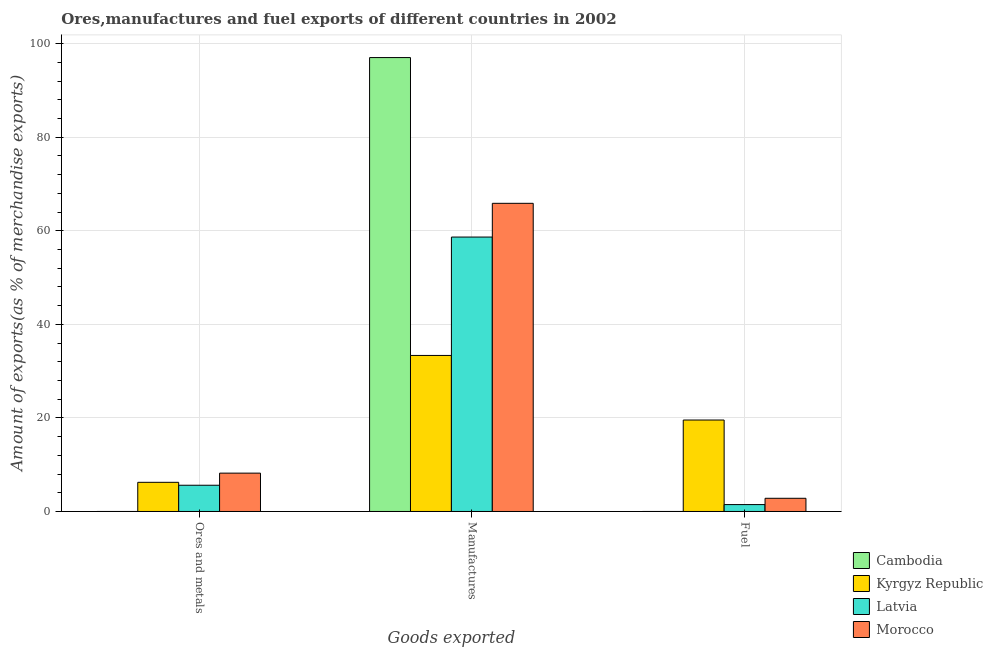How many different coloured bars are there?
Offer a terse response. 4. How many bars are there on the 2nd tick from the left?
Make the answer very short. 4. How many bars are there on the 3rd tick from the right?
Make the answer very short. 4. What is the label of the 3rd group of bars from the left?
Give a very brief answer. Fuel. What is the percentage of manufactures exports in Morocco?
Offer a terse response. 65.86. Across all countries, what is the maximum percentage of manufactures exports?
Your answer should be very brief. 97.02. Across all countries, what is the minimum percentage of manufactures exports?
Provide a short and direct response. 33.35. In which country was the percentage of fuel exports maximum?
Make the answer very short. Kyrgyz Republic. In which country was the percentage of fuel exports minimum?
Your response must be concise. Cambodia. What is the total percentage of manufactures exports in the graph?
Your answer should be compact. 254.89. What is the difference between the percentage of ores and metals exports in Cambodia and that in Morocco?
Your response must be concise. -8.2. What is the difference between the percentage of ores and metals exports in Morocco and the percentage of manufactures exports in Kyrgyz Republic?
Provide a succinct answer. -25.15. What is the average percentage of manufactures exports per country?
Offer a very short reply. 63.72. What is the difference between the percentage of manufactures exports and percentage of fuel exports in Kyrgyz Republic?
Make the answer very short. 13.8. What is the ratio of the percentage of fuel exports in Latvia to that in Cambodia?
Offer a terse response. 2388.65. Is the percentage of fuel exports in Kyrgyz Republic less than that in Latvia?
Make the answer very short. No. Is the difference between the percentage of fuel exports in Cambodia and Kyrgyz Republic greater than the difference between the percentage of manufactures exports in Cambodia and Kyrgyz Republic?
Provide a succinct answer. No. What is the difference between the highest and the second highest percentage of manufactures exports?
Ensure brevity in your answer.  31.15. What is the difference between the highest and the lowest percentage of fuel exports?
Offer a very short reply. 19.55. In how many countries, is the percentage of ores and metals exports greater than the average percentage of ores and metals exports taken over all countries?
Your answer should be compact. 3. Is the sum of the percentage of manufactures exports in Kyrgyz Republic and Cambodia greater than the maximum percentage of fuel exports across all countries?
Keep it short and to the point. Yes. What does the 3rd bar from the left in Ores and metals represents?
Ensure brevity in your answer.  Latvia. What does the 1st bar from the right in Manufactures represents?
Provide a short and direct response. Morocco. What is the difference between two consecutive major ticks on the Y-axis?
Offer a very short reply. 20. Does the graph contain any zero values?
Make the answer very short. No. Where does the legend appear in the graph?
Offer a very short reply. Bottom right. How are the legend labels stacked?
Provide a succinct answer. Vertical. What is the title of the graph?
Your response must be concise. Ores,manufactures and fuel exports of different countries in 2002. Does "Cayman Islands" appear as one of the legend labels in the graph?
Ensure brevity in your answer.  No. What is the label or title of the X-axis?
Ensure brevity in your answer.  Goods exported. What is the label or title of the Y-axis?
Ensure brevity in your answer.  Amount of exports(as % of merchandise exports). What is the Amount of exports(as % of merchandise exports) of Cambodia in Ores and metals?
Make the answer very short. 0. What is the Amount of exports(as % of merchandise exports) of Kyrgyz Republic in Ores and metals?
Offer a very short reply. 6.23. What is the Amount of exports(as % of merchandise exports) of Latvia in Ores and metals?
Your answer should be compact. 5.61. What is the Amount of exports(as % of merchandise exports) in Morocco in Ores and metals?
Give a very brief answer. 8.2. What is the Amount of exports(as % of merchandise exports) in Cambodia in Manufactures?
Provide a short and direct response. 97.02. What is the Amount of exports(as % of merchandise exports) in Kyrgyz Republic in Manufactures?
Your response must be concise. 33.35. What is the Amount of exports(as % of merchandise exports) in Latvia in Manufactures?
Offer a very short reply. 58.66. What is the Amount of exports(as % of merchandise exports) in Morocco in Manufactures?
Your answer should be compact. 65.86. What is the Amount of exports(as % of merchandise exports) of Cambodia in Fuel?
Make the answer very short. 0. What is the Amount of exports(as % of merchandise exports) in Kyrgyz Republic in Fuel?
Offer a very short reply. 19.55. What is the Amount of exports(as % of merchandise exports) in Latvia in Fuel?
Offer a terse response. 1.48. What is the Amount of exports(as % of merchandise exports) of Morocco in Fuel?
Provide a succinct answer. 2.82. Across all Goods exported, what is the maximum Amount of exports(as % of merchandise exports) in Cambodia?
Ensure brevity in your answer.  97.02. Across all Goods exported, what is the maximum Amount of exports(as % of merchandise exports) in Kyrgyz Republic?
Ensure brevity in your answer.  33.35. Across all Goods exported, what is the maximum Amount of exports(as % of merchandise exports) of Latvia?
Make the answer very short. 58.66. Across all Goods exported, what is the maximum Amount of exports(as % of merchandise exports) of Morocco?
Your answer should be very brief. 65.86. Across all Goods exported, what is the minimum Amount of exports(as % of merchandise exports) in Cambodia?
Make the answer very short. 0. Across all Goods exported, what is the minimum Amount of exports(as % of merchandise exports) of Kyrgyz Republic?
Provide a short and direct response. 6.23. Across all Goods exported, what is the minimum Amount of exports(as % of merchandise exports) of Latvia?
Offer a very short reply. 1.48. Across all Goods exported, what is the minimum Amount of exports(as % of merchandise exports) in Morocco?
Offer a very short reply. 2.82. What is the total Amount of exports(as % of merchandise exports) in Cambodia in the graph?
Offer a very short reply. 97.02. What is the total Amount of exports(as % of merchandise exports) in Kyrgyz Republic in the graph?
Give a very brief answer. 59.13. What is the total Amount of exports(as % of merchandise exports) in Latvia in the graph?
Your answer should be very brief. 65.74. What is the total Amount of exports(as % of merchandise exports) of Morocco in the graph?
Provide a short and direct response. 76.88. What is the difference between the Amount of exports(as % of merchandise exports) of Cambodia in Ores and metals and that in Manufactures?
Provide a short and direct response. -97.02. What is the difference between the Amount of exports(as % of merchandise exports) of Kyrgyz Republic in Ores and metals and that in Manufactures?
Offer a very short reply. -27.12. What is the difference between the Amount of exports(as % of merchandise exports) in Latvia in Ores and metals and that in Manufactures?
Make the answer very short. -53.05. What is the difference between the Amount of exports(as % of merchandise exports) of Morocco in Ores and metals and that in Manufactures?
Give a very brief answer. -57.67. What is the difference between the Amount of exports(as % of merchandise exports) in Cambodia in Ores and metals and that in Fuel?
Provide a succinct answer. -0. What is the difference between the Amount of exports(as % of merchandise exports) in Kyrgyz Republic in Ores and metals and that in Fuel?
Ensure brevity in your answer.  -13.31. What is the difference between the Amount of exports(as % of merchandise exports) of Latvia in Ores and metals and that in Fuel?
Give a very brief answer. 4.13. What is the difference between the Amount of exports(as % of merchandise exports) in Morocco in Ores and metals and that in Fuel?
Your answer should be compact. 5.38. What is the difference between the Amount of exports(as % of merchandise exports) in Cambodia in Manufactures and that in Fuel?
Your answer should be compact. 97.02. What is the difference between the Amount of exports(as % of merchandise exports) in Kyrgyz Republic in Manufactures and that in Fuel?
Provide a succinct answer. 13.8. What is the difference between the Amount of exports(as % of merchandise exports) in Latvia in Manufactures and that in Fuel?
Give a very brief answer. 57.18. What is the difference between the Amount of exports(as % of merchandise exports) of Morocco in Manufactures and that in Fuel?
Give a very brief answer. 63.05. What is the difference between the Amount of exports(as % of merchandise exports) of Cambodia in Ores and metals and the Amount of exports(as % of merchandise exports) of Kyrgyz Republic in Manufactures?
Ensure brevity in your answer.  -33.35. What is the difference between the Amount of exports(as % of merchandise exports) in Cambodia in Ores and metals and the Amount of exports(as % of merchandise exports) in Latvia in Manufactures?
Provide a short and direct response. -58.66. What is the difference between the Amount of exports(as % of merchandise exports) in Cambodia in Ores and metals and the Amount of exports(as % of merchandise exports) in Morocco in Manufactures?
Your answer should be compact. -65.86. What is the difference between the Amount of exports(as % of merchandise exports) in Kyrgyz Republic in Ores and metals and the Amount of exports(as % of merchandise exports) in Latvia in Manufactures?
Provide a succinct answer. -52.42. What is the difference between the Amount of exports(as % of merchandise exports) of Kyrgyz Republic in Ores and metals and the Amount of exports(as % of merchandise exports) of Morocco in Manufactures?
Keep it short and to the point. -59.63. What is the difference between the Amount of exports(as % of merchandise exports) of Latvia in Ores and metals and the Amount of exports(as % of merchandise exports) of Morocco in Manufactures?
Your response must be concise. -60.25. What is the difference between the Amount of exports(as % of merchandise exports) of Cambodia in Ores and metals and the Amount of exports(as % of merchandise exports) of Kyrgyz Republic in Fuel?
Your answer should be very brief. -19.55. What is the difference between the Amount of exports(as % of merchandise exports) of Cambodia in Ores and metals and the Amount of exports(as % of merchandise exports) of Latvia in Fuel?
Your answer should be compact. -1.48. What is the difference between the Amount of exports(as % of merchandise exports) of Cambodia in Ores and metals and the Amount of exports(as % of merchandise exports) of Morocco in Fuel?
Offer a very short reply. -2.82. What is the difference between the Amount of exports(as % of merchandise exports) in Kyrgyz Republic in Ores and metals and the Amount of exports(as % of merchandise exports) in Latvia in Fuel?
Your answer should be compact. 4.76. What is the difference between the Amount of exports(as % of merchandise exports) of Kyrgyz Republic in Ores and metals and the Amount of exports(as % of merchandise exports) of Morocco in Fuel?
Offer a very short reply. 3.42. What is the difference between the Amount of exports(as % of merchandise exports) in Latvia in Ores and metals and the Amount of exports(as % of merchandise exports) in Morocco in Fuel?
Offer a very short reply. 2.79. What is the difference between the Amount of exports(as % of merchandise exports) in Cambodia in Manufactures and the Amount of exports(as % of merchandise exports) in Kyrgyz Republic in Fuel?
Ensure brevity in your answer.  77.47. What is the difference between the Amount of exports(as % of merchandise exports) in Cambodia in Manufactures and the Amount of exports(as % of merchandise exports) in Latvia in Fuel?
Offer a very short reply. 95.54. What is the difference between the Amount of exports(as % of merchandise exports) in Cambodia in Manufactures and the Amount of exports(as % of merchandise exports) in Morocco in Fuel?
Offer a terse response. 94.2. What is the difference between the Amount of exports(as % of merchandise exports) of Kyrgyz Republic in Manufactures and the Amount of exports(as % of merchandise exports) of Latvia in Fuel?
Your answer should be very brief. 31.88. What is the difference between the Amount of exports(as % of merchandise exports) of Kyrgyz Republic in Manufactures and the Amount of exports(as % of merchandise exports) of Morocco in Fuel?
Provide a succinct answer. 30.53. What is the difference between the Amount of exports(as % of merchandise exports) of Latvia in Manufactures and the Amount of exports(as % of merchandise exports) of Morocco in Fuel?
Your response must be concise. 55.84. What is the average Amount of exports(as % of merchandise exports) in Cambodia per Goods exported?
Provide a succinct answer. 32.34. What is the average Amount of exports(as % of merchandise exports) in Kyrgyz Republic per Goods exported?
Offer a terse response. 19.71. What is the average Amount of exports(as % of merchandise exports) of Latvia per Goods exported?
Provide a short and direct response. 21.91. What is the average Amount of exports(as % of merchandise exports) of Morocco per Goods exported?
Give a very brief answer. 25.63. What is the difference between the Amount of exports(as % of merchandise exports) of Cambodia and Amount of exports(as % of merchandise exports) of Kyrgyz Republic in Ores and metals?
Your answer should be compact. -6.23. What is the difference between the Amount of exports(as % of merchandise exports) of Cambodia and Amount of exports(as % of merchandise exports) of Latvia in Ores and metals?
Offer a terse response. -5.61. What is the difference between the Amount of exports(as % of merchandise exports) of Cambodia and Amount of exports(as % of merchandise exports) of Morocco in Ores and metals?
Offer a terse response. -8.2. What is the difference between the Amount of exports(as % of merchandise exports) in Kyrgyz Republic and Amount of exports(as % of merchandise exports) in Latvia in Ores and metals?
Give a very brief answer. 0.62. What is the difference between the Amount of exports(as % of merchandise exports) of Kyrgyz Republic and Amount of exports(as % of merchandise exports) of Morocco in Ores and metals?
Your answer should be very brief. -1.96. What is the difference between the Amount of exports(as % of merchandise exports) in Latvia and Amount of exports(as % of merchandise exports) in Morocco in Ores and metals?
Give a very brief answer. -2.59. What is the difference between the Amount of exports(as % of merchandise exports) in Cambodia and Amount of exports(as % of merchandise exports) in Kyrgyz Republic in Manufactures?
Provide a short and direct response. 63.67. What is the difference between the Amount of exports(as % of merchandise exports) of Cambodia and Amount of exports(as % of merchandise exports) of Latvia in Manufactures?
Your answer should be compact. 38.36. What is the difference between the Amount of exports(as % of merchandise exports) of Cambodia and Amount of exports(as % of merchandise exports) of Morocco in Manufactures?
Give a very brief answer. 31.15. What is the difference between the Amount of exports(as % of merchandise exports) of Kyrgyz Republic and Amount of exports(as % of merchandise exports) of Latvia in Manufactures?
Give a very brief answer. -25.31. What is the difference between the Amount of exports(as % of merchandise exports) in Kyrgyz Republic and Amount of exports(as % of merchandise exports) in Morocco in Manufactures?
Your answer should be compact. -32.51. What is the difference between the Amount of exports(as % of merchandise exports) in Latvia and Amount of exports(as % of merchandise exports) in Morocco in Manufactures?
Offer a very short reply. -7.21. What is the difference between the Amount of exports(as % of merchandise exports) in Cambodia and Amount of exports(as % of merchandise exports) in Kyrgyz Republic in Fuel?
Provide a short and direct response. -19.55. What is the difference between the Amount of exports(as % of merchandise exports) of Cambodia and Amount of exports(as % of merchandise exports) of Latvia in Fuel?
Offer a very short reply. -1.48. What is the difference between the Amount of exports(as % of merchandise exports) in Cambodia and Amount of exports(as % of merchandise exports) in Morocco in Fuel?
Your response must be concise. -2.82. What is the difference between the Amount of exports(as % of merchandise exports) of Kyrgyz Republic and Amount of exports(as % of merchandise exports) of Latvia in Fuel?
Offer a very short reply. 18.07. What is the difference between the Amount of exports(as % of merchandise exports) of Kyrgyz Republic and Amount of exports(as % of merchandise exports) of Morocco in Fuel?
Provide a short and direct response. 16.73. What is the difference between the Amount of exports(as % of merchandise exports) in Latvia and Amount of exports(as % of merchandise exports) in Morocco in Fuel?
Your response must be concise. -1.34. What is the ratio of the Amount of exports(as % of merchandise exports) in Kyrgyz Republic in Ores and metals to that in Manufactures?
Your answer should be compact. 0.19. What is the ratio of the Amount of exports(as % of merchandise exports) in Latvia in Ores and metals to that in Manufactures?
Your answer should be very brief. 0.1. What is the ratio of the Amount of exports(as % of merchandise exports) in Morocco in Ores and metals to that in Manufactures?
Ensure brevity in your answer.  0.12. What is the ratio of the Amount of exports(as % of merchandise exports) of Cambodia in Ores and metals to that in Fuel?
Your answer should be very brief. 0.97. What is the ratio of the Amount of exports(as % of merchandise exports) in Kyrgyz Republic in Ores and metals to that in Fuel?
Provide a succinct answer. 0.32. What is the ratio of the Amount of exports(as % of merchandise exports) of Latvia in Ores and metals to that in Fuel?
Provide a short and direct response. 3.8. What is the ratio of the Amount of exports(as % of merchandise exports) of Morocco in Ores and metals to that in Fuel?
Provide a short and direct response. 2.91. What is the ratio of the Amount of exports(as % of merchandise exports) of Cambodia in Manufactures to that in Fuel?
Provide a succinct answer. 1.57e+05. What is the ratio of the Amount of exports(as % of merchandise exports) of Kyrgyz Republic in Manufactures to that in Fuel?
Ensure brevity in your answer.  1.71. What is the ratio of the Amount of exports(as % of merchandise exports) in Latvia in Manufactures to that in Fuel?
Make the answer very short. 39.75. What is the ratio of the Amount of exports(as % of merchandise exports) of Morocco in Manufactures to that in Fuel?
Your answer should be very brief. 23.37. What is the difference between the highest and the second highest Amount of exports(as % of merchandise exports) of Cambodia?
Provide a succinct answer. 97.02. What is the difference between the highest and the second highest Amount of exports(as % of merchandise exports) in Kyrgyz Republic?
Ensure brevity in your answer.  13.8. What is the difference between the highest and the second highest Amount of exports(as % of merchandise exports) of Latvia?
Your answer should be compact. 53.05. What is the difference between the highest and the second highest Amount of exports(as % of merchandise exports) in Morocco?
Offer a terse response. 57.67. What is the difference between the highest and the lowest Amount of exports(as % of merchandise exports) of Cambodia?
Give a very brief answer. 97.02. What is the difference between the highest and the lowest Amount of exports(as % of merchandise exports) in Kyrgyz Republic?
Offer a terse response. 27.12. What is the difference between the highest and the lowest Amount of exports(as % of merchandise exports) in Latvia?
Ensure brevity in your answer.  57.18. What is the difference between the highest and the lowest Amount of exports(as % of merchandise exports) of Morocco?
Keep it short and to the point. 63.05. 